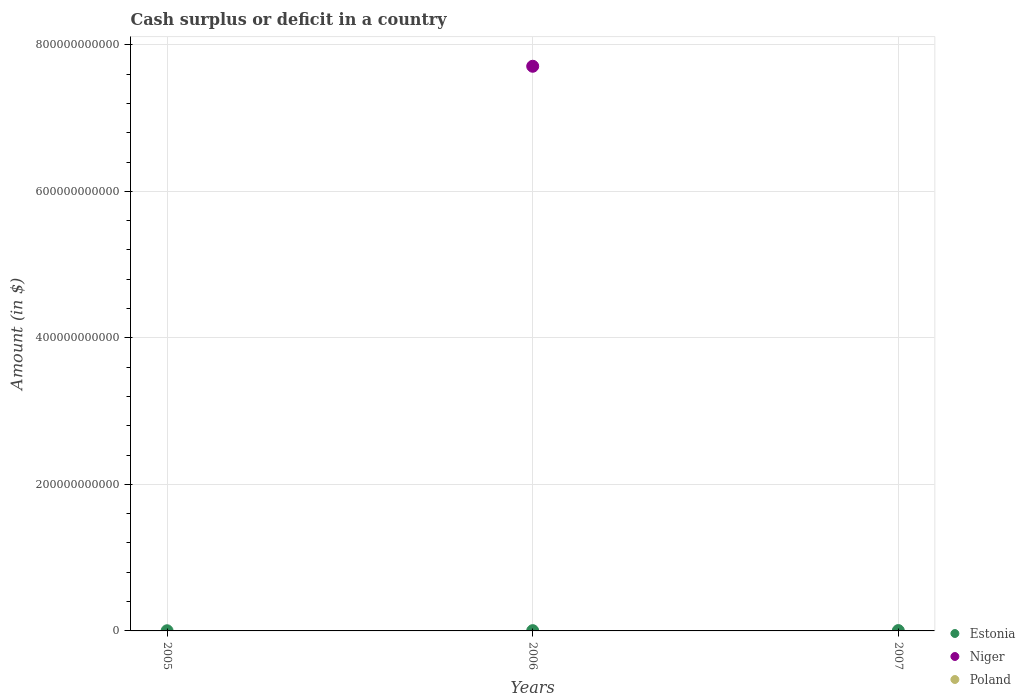What is the amount of cash surplus or deficit in Estonia in 2005?
Your answer should be compact. 2.19e+08. Across all years, what is the maximum amount of cash surplus or deficit in Niger?
Your answer should be compact. 7.71e+11. In which year was the amount of cash surplus or deficit in Niger maximum?
Keep it short and to the point. 2006. What is the total amount of cash surplus or deficit in Estonia in the graph?
Your answer should be very brief. 1.03e+09. What is the difference between the amount of cash surplus or deficit in Estonia in 2006 and that in 2007?
Provide a short and direct response. -1.05e+08. What is the difference between the amount of cash surplus or deficit in Estonia in 2006 and the amount of cash surplus or deficit in Poland in 2007?
Your answer should be very brief. 3.52e+08. In the year 2006, what is the difference between the amount of cash surplus or deficit in Niger and amount of cash surplus or deficit in Estonia?
Your answer should be very brief. 7.70e+11. In how many years, is the amount of cash surplus or deficit in Niger greater than 240000000000 $?
Your response must be concise. 1. What is the ratio of the amount of cash surplus or deficit in Estonia in 2005 to that in 2006?
Give a very brief answer. 0.62. What is the difference between the highest and the second highest amount of cash surplus or deficit in Estonia?
Your response must be concise. 1.05e+08. What is the difference between the highest and the lowest amount of cash surplus or deficit in Niger?
Provide a succinct answer. 7.71e+11. In how many years, is the amount of cash surplus or deficit in Estonia greater than the average amount of cash surplus or deficit in Estonia taken over all years?
Provide a succinct answer. 2. Is it the case that in every year, the sum of the amount of cash surplus or deficit in Niger and amount of cash surplus or deficit in Poland  is greater than the amount of cash surplus or deficit in Estonia?
Ensure brevity in your answer.  No. Does the amount of cash surplus or deficit in Niger monotonically increase over the years?
Offer a very short reply. No. Is the amount of cash surplus or deficit in Poland strictly greater than the amount of cash surplus or deficit in Niger over the years?
Keep it short and to the point. No. How many dotlines are there?
Your response must be concise. 2. What is the difference between two consecutive major ticks on the Y-axis?
Keep it short and to the point. 2.00e+11. How many legend labels are there?
Provide a short and direct response. 3. How are the legend labels stacked?
Make the answer very short. Vertical. What is the title of the graph?
Ensure brevity in your answer.  Cash surplus or deficit in a country. What is the label or title of the X-axis?
Your response must be concise. Years. What is the label or title of the Y-axis?
Keep it short and to the point. Amount (in $). What is the Amount (in $) in Estonia in 2005?
Ensure brevity in your answer.  2.19e+08. What is the Amount (in $) of Niger in 2005?
Offer a very short reply. 0. What is the Amount (in $) of Poland in 2005?
Your response must be concise. 0. What is the Amount (in $) in Estonia in 2006?
Provide a succinct answer. 3.52e+08. What is the Amount (in $) of Niger in 2006?
Ensure brevity in your answer.  7.71e+11. What is the Amount (in $) in Poland in 2006?
Offer a very short reply. 0. What is the Amount (in $) of Estonia in 2007?
Keep it short and to the point. 4.56e+08. What is the Amount (in $) of Poland in 2007?
Offer a terse response. 0. Across all years, what is the maximum Amount (in $) in Estonia?
Ensure brevity in your answer.  4.56e+08. Across all years, what is the maximum Amount (in $) of Niger?
Give a very brief answer. 7.71e+11. Across all years, what is the minimum Amount (in $) of Estonia?
Provide a succinct answer. 2.19e+08. Across all years, what is the minimum Amount (in $) in Niger?
Your response must be concise. 0. What is the total Amount (in $) of Estonia in the graph?
Give a very brief answer. 1.03e+09. What is the total Amount (in $) of Niger in the graph?
Your response must be concise. 7.71e+11. What is the total Amount (in $) in Poland in the graph?
Ensure brevity in your answer.  0. What is the difference between the Amount (in $) of Estonia in 2005 and that in 2006?
Your answer should be compact. -1.32e+08. What is the difference between the Amount (in $) in Estonia in 2005 and that in 2007?
Provide a short and direct response. -2.37e+08. What is the difference between the Amount (in $) of Estonia in 2006 and that in 2007?
Keep it short and to the point. -1.05e+08. What is the difference between the Amount (in $) of Estonia in 2005 and the Amount (in $) of Niger in 2006?
Provide a short and direct response. -7.70e+11. What is the average Amount (in $) in Estonia per year?
Provide a short and direct response. 3.42e+08. What is the average Amount (in $) in Niger per year?
Give a very brief answer. 2.57e+11. In the year 2006, what is the difference between the Amount (in $) in Estonia and Amount (in $) in Niger?
Offer a terse response. -7.70e+11. What is the ratio of the Amount (in $) in Estonia in 2005 to that in 2006?
Keep it short and to the point. 0.62. What is the ratio of the Amount (in $) of Estonia in 2005 to that in 2007?
Make the answer very short. 0.48. What is the ratio of the Amount (in $) in Estonia in 2006 to that in 2007?
Offer a very short reply. 0.77. What is the difference between the highest and the second highest Amount (in $) in Estonia?
Ensure brevity in your answer.  1.05e+08. What is the difference between the highest and the lowest Amount (in $) in Estonia?
Provide a short and direct response. 2.37e+08. What is the difference between the highest and the lowest Amount (in $) of Niger?
Offer a terse response. 7.71e+11. 